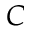Convert formula to latex. <formula><loc_0><loc_0><loc_500><loc_500>C</formula> 